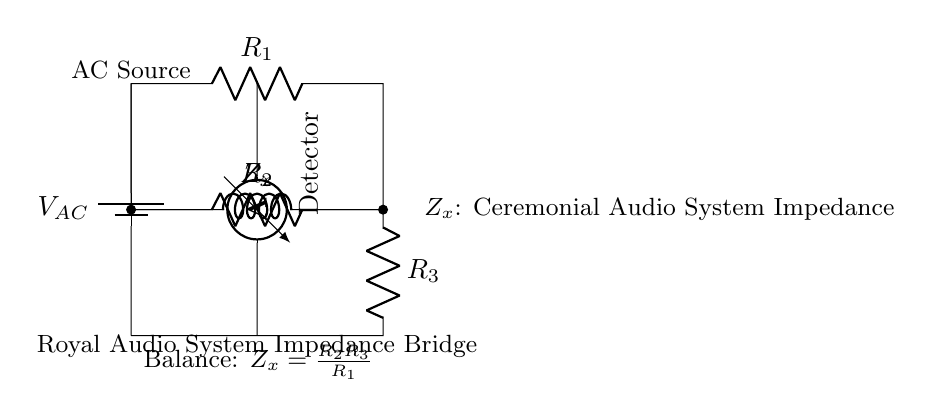What type of circuit is shown in the diagram? The diagram depicts a bridge circuit used for impedance measurement, specifically for balancing the impedances of a known resistor and an unknown impedance.
Answer: Bridge circuit What does the inductor represent in the circuit? The inductor labeled as Zx represents the impedance of the ceremonial audio system that is being tested within the bridge circuit.
Answer: Ceremonial Audio System Impedance What is the purpose of the voltmeter in this circuit? The voltmeter, identified as the "Detector," is used to measure the voltage difference between the two points in the circuit, helping to determine when the bridge is balanced.
Answer: Voltage measurement What is the balance condition for this AC bridge circuit? The balance condition is provided by the equation Zx = (R2 * R3) / R1, indicating when the unknown impedance matches the calculated impedance based on the resistors in the circuit.
Answer: Zx = R2 * R3 / R1 What can be inferred about the relationship between the resistors R1, R2, and R3? The resistors R1, R2, and R3 must be selected such that their values create a match with the impedance Zx for balancing, which is vital for accurate measurements in the circuit.
Answer: Required for balancing What is the voltage source type in this circuit? The circuit uses an alternating current source as indicated by the label V_AC, which is necessary for the impedance testing process.
Answer: AC source 